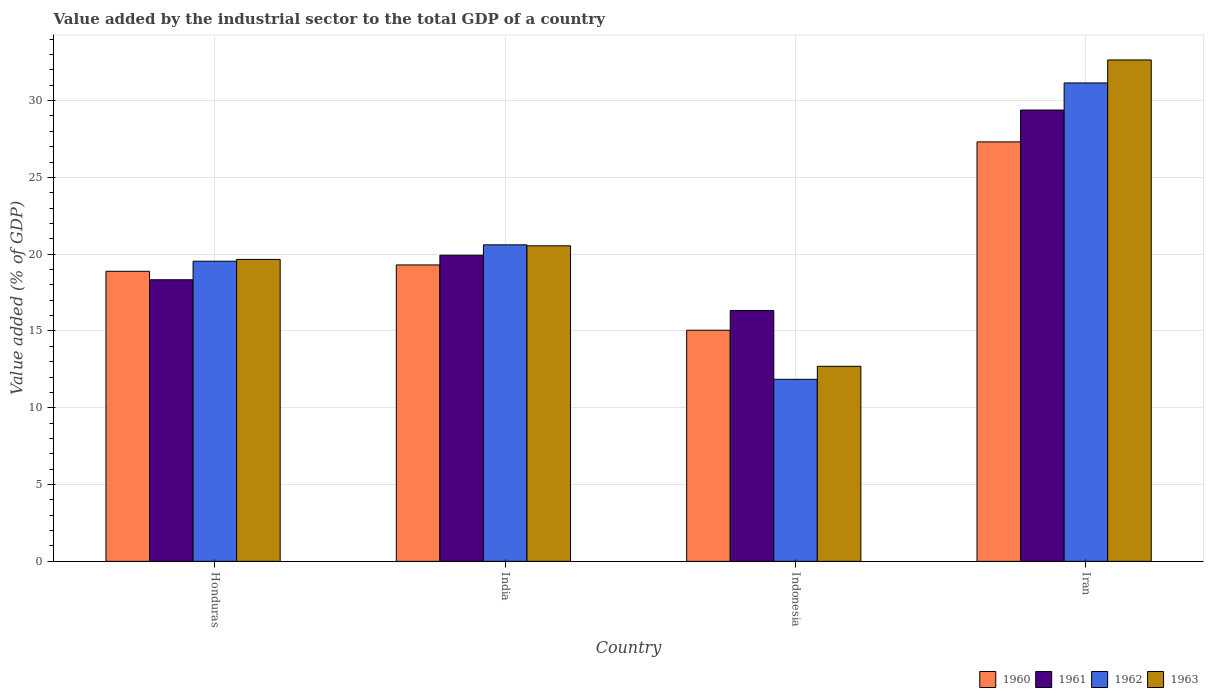How many groups of bars are there?
Give a very brief answer. 4. How many bars are there on the 3rd tick from the left?
Make the answer very short. 4. What is the label of the 1st group of bars from the left?
Make the answer very short. Honduras. What is the value added by the industrial sector to the total GDP in 1961 in India?
Ensure brevity in your answer.  19.93. Across all countries, what is the maximum value added by the industrial sector to the total GDP in 1962?
Your answer should be compact. 31.15. Across all countries, what is the minimum value added by the industrial sector to the total GDP in 1961?
Your response must be concise. 16.33. In which country was the value added by the industrial sector to the total GDP in 1962 maximum?
Your answer should be very brief. Iran. In which country was the value added by the industrial sector to the total GDP in 1963 minimum?
Provide a short and direct response. Indonesia. What is the total value added by the industrial sector to the total GDP in 1962 in the graph?
Your response must be concise. 83.15. What is the difference between the value added by the industrial sector to the total GDP in 1960 in Honduras and that in Iran?
Your response must be concise. -8.43. What is the difference between the value added by the industrial sector to the total GDP in 1961 in India and the value added by the industrial sector to the total GDP in 1963 in Honduras?
Ensure brevity in your answer.  0.27. What is the average value added by the industrial sector to the total GDP in 1962 per country?
Your response must be concise. 20.79. What is the difference between the value added by the industrial sector to the total GDP of/in 1960 and value added by the industrial sector to the total GDP of/in 1962 in Iran?
Make the answer very short. -3.84. What is the ratio of the value added by the industrial sector to the total GDP in 1962 in India to that in Iran?
Provide a succinct answer. 0.66. Is the difference between the value added by the industrial sector to the total GDP in 1960 in Honduras and Iran greater than the difference between the value added by the industrial sector to the total GDP in 1962 in Honduras and Iran?
Offer a terse response. Yes. What is the difference between the highest and the second highest value added by the industrial sector to the total GDP in 1960?
Provide a short and direct response. 0.41. What is the difference between the highest and the lowest value added by the industrial sector to the total GDP in 1963?
Your answer should be compact. 19.95. In how many countries, is the value added by the industrial sector to the total GDP in 1960 greater than the average value added by the industrial sector to the total GDP in 1960 taken over all countries?
Keep it short and to the point. 1. Is the sum of the value added by the industrial sector to the total GDP in 1961 in Honduras and Iran greater than the maximum value added by the industrial sector to the total GDP in 1962 across all countries?
Keep it short and to the point. Yes. Is it the case that in every country, the sum of the value added by the industrial sector to the total GDP in 1961 and value added by the industrial sector to the total GDP in 1960 is greater than the sum of value added by the industrial sector to the total GDP in 1963 and value added by the industrial sector to the total GDP in 1962?
Provide a short and direct response. No. What does the 4th bar from the left in Iran represents?
Your answer should be compact. 1963. What does the 1st bar from the right in Indonesia represents?
Offer a terse response. 1963. How many bars are there?
Ensure brevity in your answer.  16. How many countries are there in the graph?
Ensure brevity in your answer.  4. What is the difference between two consecutive major ticks on the Y-axis?
Offer a terse response. 5. Are the values on the major ticks of Y-axis written in scientific E-notation?
Your answer should be very brief. No. Does the graph contain any zero values?
Make the answer very short. No. What is the title of the graph?
Your answer should be compact. Value added by the industrial sector to the total GDP of a country. Does "2001" appear as one of the legend labels in the graph?
Offer a terse response. No. What is the label or title of the Y-axis?
Provide a succinct answer. Value added (% of GDP). What is the Value added (% of GDP) in 1960 in Honduras?
Your answer should be very brief. 18.89. What is the Value added (% of GDP) of 1961 in Honduras?
Make the answer very short. 18.33. What is the Value added (% of GDP) of 1962 in Honduras?
Your answer should be compact. 19.54. What is the Value added (% of GDP) in 1963 in Honduras?
Keep it short and to the point. 19.66. What is the Value added (% of GDP) of 1960 in India?
Ensure brevity in your answer.  19.3. What is the Value added (% of GDP) in 1961 in India?
Offer a terse response. 19.93. What is the Value added (% of GDP) in 1962 in India?
Make the answer very short. 20.61. What is the Value added (% of GDP) of 1963 in India?
Provide a short and direct response. 20.54. What is the Value added (% of GDP) of 1960 in Indonesia?
Make the answer very short. 15.05. What is the Value added (% of GDP) of 1961 in Indonesia?
Keep it short and to the point. 16.33. What is the Value added (% of GDP) in 1962 in Indonesia?
Your response must be concise. 11.85. What is the Value added (% of GDP) of 1963 in Indonesia?
Provide a succinct answer. 12.7. What is the Value added (% of GDP) of 1960 in Iran?
Your response must be concise. 27.31. What is the Value added (% of GDP) of 1961 in Iran?
Give a very brief answer. 29.38. What is the Value added (% of GDP) of 1962 in Iran?
Give a very brief answer. 31.15. What is the Value added (% of GDP) of 1963 in Iran?
Offer a very short reply. 32.65. Across all countries, what is the maximum Value added (% of GDP) in 1960?
Make the answer very short. 27.31. Across all countries, what is the maximum Value added (% of GDP) of 1961?
Your answer should be compact. 29.38. Across all countries, what is the maximum Value added (% of GDP) of 1962?
Offer a very short reply. 31.15. Across all countries, what is the maximum Value added (% of GDP) of 1963?
Offer a terse response. 32.65. Across all countries, what is the minimum Value added (% of GDP) of 1960?
Ensure brevity in your answer.  15.05. Across all countries, what is the minimum Value added (% of GDP) of 1961?
Give a very brief answer. 16.33. Across all countries, what is the minimum Value added (% of GDP) of 1962?
Keep it short and to the point. 11.85. Across all countries, what is the minimum Value added (% of GDP) in 1963?
Ensure brevity in your answer.  12.7. What is the total Value added (% of GDP) in 1960 in the graph?
Your response must be concise. 80.55. What is the total Value added (% of GDP) in 1961 in the graph?
Offer a terse response. 83.98. What is the total Value added (% of GDP) of 1962 in the graph?
Your response must be concise. 83.15. What is the total Value added (% of GDP) of 1963 in the graph?
Give a very brief answer. 85.55. What is the difference between the Value added (% of GDP) in 1960 in Honduras and that in India?
Provide a succinct answer. -0.41. What is the difference between the Value added (% of GDP) in 1961 in Honduras and that in India?
Give a very brief answer. -1.6. What is the difference between the Value added (% of GDP) of 1962 in Honduras and that in India?
Give a very brief answer. -1.07. What is the difference between the Value added (% of GDP) of 1963 in Honduras and that in India?
Your answer should be very brief. -0.88. What is the difference between the Value added (% of GDP) of 1960 in Honduras and that in Indonesia?
Provide a succinct answer. 3.84. What is the difference between the Value added (% of GDP) in 1961 in Honduras and that in Indonesia?
Give a very brief answer. 2. What is the difference between the Value added (% of GDP) in 1962 in Honduras and that in Indonesia?
Give a very brief answer. 7.69. What is the difference between the Value added (% of GDP) in 1963 in Honduras and that in Indonesia?
Keep it short and to the point. 6.96. What is the difference between the Value added (% of GDP) in 1960 in Honduras and that in Iran?
Ensure brevity in your answer.  -8.43. What is the difference between the Value added (% of GDP) of 1961 in Honduras and that in Iran?
Provide a short and direct response. -11.05. What is the difference between the Value added (% of GDP) of 1962 in Honduras and that in Iran?
Give a very brief answer. -11.61. What is the difference between the Value added (% of GDP) of 1963 in Honduras and that in Iran?
Offer a terse response. -12.99. What is the difference between the Value added (% of GDP) in 1960 in India and that in Indonesia?
Keep it short and to the point. 4.25. What is the difference between the Value added (% of GDP) in 1961 in India and that in Indonesia?
Offer a terse response. 3.6. What is the difference between the Value added (% of GDP) in 1962 in India and that in Indonesia?
Give a very brief answer. 8.76. What is the difference between the Value added (% of GDP) of 1963 in India and that in Indonesia?
Give a very brief answer. 7.84. What is the difference between the Value added (% of GDP) in 1960 in India and that in Iran?
Offer a very short reply. -8.01. What is the difference between the Value added (% of GDP) of 1961 in India and that in Iran?
Make the answer very short. -9.45. What is the difference between the Value added (% of GDP) of 1962 in India and that in Iran?
Offer a very short reply. -10.54. What is the difference between the Value added (% of GDP) in 1963 in India and that in Iran?
Provide a succinct answer. -12.1. What is the difference between the Value added (% of GDP) of 1960 in Indonesia and that in Iran?
Provide a short and direct response. -12.26. What is the difference between the Value added (% of GDP) of 1961 in Indonesia and that in Iran?
Ensure brevity in your answer.  -13.05. What is the difference between the Value added (% of GDP) in 1962 in Indonesia and that in Iran?
Provide a short and direct response. -19.3. What is the difference between the Value added (% of GDP) in 1963 in Indonesia and that in Iran?
Keep it short and to the point. -19.95. What is the difference between the Value added (% of GDP) in 1960 in Honduras and the Value added (% of GDP) in 1961 in India?
Give a very brief answer. -1.05. What is the difference between the Value added (% of GDP) of 1960 in Honduras and the Value added (% of GDP) of 1962 in India?
Make the answer very short. -1.72. What is the difference between the Value added (% of GDP) of 1960 in Honduras and the Value added (% of GDP) of 1963 in India?
Offer a very short reply. -1.66. What is the difference between the Value added (% of GDP) in 1961 in Honduras and the Value added (% of GDP) in 1962 in India?
Provide a succinct answer. -2.27. What is the difference between the Value added (% of GDP) of 1961 in Honduras and the Value added (% of GDP) of 1963 in India?
Your answer should be compact. -2.21. What is the difference between the Value added (% of GDP) of 1962 in Honduras and the Value added (% of GDP) of 1963 in India?
Give a very brief answer. -1. What is the difference between the Value added (% of GDP) in 1960 in Honduras and the Value added (% of GDP) in 1961 in Indonesia?
Make the answer very short. 2.56. What is the difference between the Value added (% of GDP) in 1960 in Honduras and the Value added (% of GDP) in 1962 in Indonesia?
Offer a very short reply. 7.03. What is the difference between the Value added (% of GDP) in 1960 in Honduras and the Value added (% of GDP) in 1963 in Indonesia?
Your answer should be very brief. 6.19. What is the difference between the Value added (% of GDP) in 1961 in Honduras and the Value added (% of GDP) in 1962 in Indonesia?
Your answer should be compact. 6.48. What is the difference between the Value added (% of GDP) in 1961 in Honduras and the Value added (% of GDP) in 1963 in Indonesia?
Your response must be concise. 5.64. What is the difference between the Value added (% of GDP) in 1962 in Honduras and the Value added (% of GDP) in 1963 in Indonesia?
Make the answer very short. 6.84. What is the difference between the Value added (% of GDP) of 1960 in Honduras and the Value added (% of GDP) of 1961 in Iran?
Keep it short and to the point. -10.5. What is the difference between the Value added (% of GDP) in 1960 in Honduras and the Value added (% of GDP) in 1962 in Iran?
Make the answer very short. -12.26. What is the difference between the Value added (% of GDP) of 1960 in Honduras and the Value added (% of GDP) of 1963 in Iran?
Your answer should be compact. -13.76. What is the difference between the Value added (% of GDP) of 1961 in Honduras and the Value added (% of GDP) of 1962 in Iran?
Make the answer very short. -12.81. What is the difference between the Value added (% of GDP) in 1961 in Honduras and the Value added (% of GDP) in 1963 in Iran?
Your answer should be very brief. -14.31. What is the difference between the Value added (% of GDP) in 1962 in Honduras and the Value added (% of GDP) in 1963 in Iran?
Keep it short and to the point. -13.1. What is the difference between the Value added (% of GDP) of 1960 in India and the Value added (% of GDP) of 1961 in Indonesia?
Provide a succinct answer. 2.97. What is the difference between the Value added (% of GDP) in 1960 in India and the Value added (% of GDP) in 1962 in Indonesia?
Keep it short and to the point. 7.45. What is the difference between the Value added (% of GDP) of 1960 in India and the Value added (% of GDP) of 1963 in Indonesia?
Make the answer very short. 6.6. What is the difference between the Value added (% of GDP) of 1961 in India and the Value added (% of GDP) of 1962 in Indonesia?
Ensure brevity in your answer.  8.08. What is the difference between the Value added (% of GDP) in 1961 in India and the Value added (% of GDP) in 1963 in Indonesia?
Provide a short and direct response. 7.23. What is the difference between the Value added (% of GDP) of 1962 in India and the Value added (% of GDP) of 1963 in Indonesia?
Your response must be concise. 7.91. What is the difference between the Value added (% of GDP) in 1960 in India and the Value added (% of GDP) in 1961 in Iran?
Make the answer very short. -10.09. What is the difference between the Value added (% of GDP) in 1960 in India and the Value added (% of GDP) in 1962 in Iran?
Make the answer very short. -11.85. What is the difference between the Value added (% of GDP) of 1960 in India and the Value added (% of GDP) of 1963 in Iran?
Give a very brief answer. -13.35. What is the difference between the Value added (% of GDP) in 1961 in India and the Value added (% of GDP) in 1962 in Iran?
Your answer should be very brief. -11.22. What is the difference between the Value added (% of GDP) of 1961 in India and the Value added (% of GDP) of 1963 in Iran?
Provide a succinct answer. -12.71. What is the difference between the Value added (% of GDP) of 1962 in India and the Value added (% of GDP) of 1963 in Iran?
Make the answer very short. -12.04. What is the difference between the Value added (% of GDP) in 1960 in Indonesia and the Value added (% of GDP) in 1961 in Iran?
Your answer should be very brief. -14.34. What is the difference between the Value added (% of GDP) of 1960 in Indonesia and the Value added (% of GDP) of 1962 in Iran?
Provide a succinct answer. -16.1. What is the difference between the Value added (% of GDP) in 1960 in Indonesia and the Value added (% of GDP) in 1963 in Iran?
Give a very brief answer. -17.6. What is the difference between the Value added (% of GDP) in 1961 in Indonesia and the Value added (% of GDP) in 1962 in Iran?
Provide a succinct answer. -14.82. What is the difference between the Value added (% of GDP) in 1961 in Indonesia and the Value added (% of GDP) in 1963 in Iran?
Keep it short and to the point. -16.32. What is the difference between the Value added (% of GDP) in 1962 in Indonesia and the Value added (% of GDP) in 1963 in Iran?
Provide a short and direct response. -20.79. What is the average Value added (% of GDP) in 1960 per country?
Provide a succinct answer. 20.14. What is the average Value added (% of GDP) in 1961 per country?
Provide a short and direct response. 21. What is the average Value added (% of GDP) in 1962 per country?
Offer a very short reply. 20.79. What is the average Value added (% of GDP) in 1963 per country?
Provide a short and direct response. 21.39. What is the difference between the Value added (% of GDP) of 1960 and Value added (% of GDP) of 1961 in Honduras?
Provide a succinct answer. 0.55. What is the difference between the Value added (% of GDP) of 1960 and Value added (% of GDP) of 1962 in Honduras?
Make the answer very short. -0.66. What is the difference between the Value added (% of GDP) of 1960 and Value added (% of GDP) of 1963 in Honduras?
Offer a terse response. -0.77. What is the difference between the Value added (% of GDP) in 1961 and Value added (% of GDP) in 1962 in Honduras?
Ensure brevity in your answer.  -1.21. What is the difference between the Value added (% of GDP) of 1961 and Value added (% of GDP) of 1963 in Honduras?
Give a very brief answer. -1.32. What is the difference between the Value added (% of GDP) in 1962 and Value added (% of GDP) in 1963 in Honduras?
Ensure brevity in your answer.  -0.12. What is the difference between the Value added (% of GDP) in 1960 and Value added (% of GDP) in 1961 in India?
Ensure brevity in your answer.  -0.63. What is the difference between the Value added (% of GDP) in 1960 and Value added (% of GDP) in 1962 in India?
Your answer should be very brief. -1.31. What is the difference between the Value added (% of GDP) in 1960 and Value added (% of GDP) in 1963 in India?
Your response must be concise. -1.24. What is the difference between the Value added (% of GDP) of 1961 and Value added (% of GDP) of 1962 in India?
Keep it short and to the point. -0.68. What is the difference between the Value added (% of GDP) in 1961 and Value added (% of GDP) in 1963 in India?
Your response must be concise. -0.61. What is the difference between the Value added (% of GDP) of 1962 and Value added (% of GDP) of 1963 in India?
Make the answer very short. 0.06. What is the difference between the Value added (% of GDP) in 1960 and Value added (% of GDP) in 1961 in Indonesia?
Your response must be concise. -1.28. What is the difference between the Value added (% of GDP) of 1960 and Value added (% of GDP) of 1962 in Indonesia?
Offer a very short reply. 3.2. What is the difference between the Value added (% of GDP) of 1960 and Value added (% of GDP) of 1963 in Indonesia?
Ensure brevity in your answer.  2.35. What is the difference between the Value added (% of GDP) in 1961 and Value added (% of GDP) in 1962 in Indonesia?
Your response must be concise. 4.48. What is the difference between the Value added (% of GDP) of 1961 and Value added (% of GDP) of 1963 in Indonesia?
Provide a short and direct response. 3.63. What is the difference between the Value added (% of GDP) of 1962 and Value added (% of GDP) of 1963 in Indonesia?
Give a very brief answer. -0.85. What is the difference between the Value added (% of GDP) of 1960 and Value added (% of GDP) of 1961 in Iran?
Ensure brevity in your answer.  -2.07. What is the difference between the Value added (% of GDP) in 1960 and Value added (% of GDP) in 1962 in Iran?
Ensure brevity in your answer.  -3.84. What is the difference between the Value added (% of GDP) of 1960 and Value added (% of GDP) of 1963 in Iran?
Your answer should be compact. -5.33. What is the difference between the Value added (% of GDP) in 1961 and Value added (% of GDP) in 1962 in Iran?
Offer a terse response. -1.76. What is the difference between the Value added (% of GDP) of 1961 and Value added (% of GDP) of 1963 in Iran?
Your answer should be very brief. -3.26. What is the difference between the Value added (% of GDP) in 1962 and Value added (% of GDP) in 1963 in Iran?
Make the answer very short. -1.5. What is the ratio of the Value added (% of GDP) of 1960 in Honduras to that in India?
Your answer should be compact. 0.98. What is the ratio of the Value added (% of GDP) of 1961 in Honduras to that in India?
Your answer should be very brief. 0.92. What is the ratio of the Value added (% of GDP) of 1962 in Honduras to that in India?
Give a very brief answer. 0.95. What is the ratio of the Value added (% of GDP) of 1963 in Honduras to that in India?
Your response must be concise. 0.96. What is the ratio of the Value added (% of GDP) of 1960 in Honduras to that in Indonesia?
Provide a short and direct response. 1.25. What is the ratio of the Value added (% of GDP) of 1961 in Honduras to that in Indonesia?
Give a very brief answer. 1.12. What is the ratio of the Value added (% of GDP) in 1962 in Honduras to that in Indonesia?
Your response must be concise. 1.65. What is the ratio of the Value added (% of GDP) of 1963 in Honduras to that in Indonesia?
Offer a very short reply. 1.55. What is the ratio of the Value added (% of GDP) of 1960 in Honduras to that in Iran?
Make the answer very short. 0.69. What is the ratio of the Value added (% of GDP) in 1961 in Honduras to that in Iran?
Give a very brief answer. 0.62. What is the ratio of the Value added (% of GDP) of 1962 in Honduras to that in Iran?
Ensure brevity in your answer.  0.63. What is the ratio of the Value added (% of GDP) in 1963 in Honduras to that in Iran?
Offer a very short reply. 0.6. What is the ratio of the Value added (% of GDP) in 1960 in India to that in Indonesia?
Your response must be concise. 1.28. What is the ratio of the Value added (% of GDP) in 1961 in India to that in Indonesia?
Provide a succinct answer. 1.22. What is the ratio of the Value added (% of GDP) in 1962 in India to that in Indonesia?
Offer a very short reply. 1.74. What is the ratio of the Value added (% of GDP) of 1963 in India to that in Indonesia?
Keep it short and to the point. 1.62. What is the ratio of the Value added (% of GDP) in 1960 in India to that in Iran?
Your response must be concise. 0.71. What is the ratio of the Value added (% of GDP) of 1961 in India to that in Iran?
Keep it short and to the point. 0.68. What is the ratio of the Value added (% of GDP) of 1962 in India to that in Iran?
Keep it short and to the point. 0.66. What is the ratio of the Value added (% of GDP) of 1963 in India to that in Iran?
Ensure brevity in your answer.  0.63. What is the ratio of the Value added (% of GDP) of 1960 in Indonesia to that in Iran?
Ensure brevity in your answer.  0.55. What is the ratio of the Value added (% of GDP) in 1961 in Indonesia to that in Iran?
Provide a succinct answer. 0.56. What is the ratio of the Value added (% of GDP) of 1962 in Indonesia to that in Iran?
Give a very brief answer. 0.38. What is the ratio of the Value added (% of GDP) of 1963 in Indonesia to that in Iran?
Give a very brief answer. 0.39. What is the difference between the highest and the second highest Value added (% of GDP) of 1960?
Provide a succinct answer. 8.01. What is the difference between the highest and the second highest Value added (% of GDP) in 1961?
Offer a terse response. 9.45. What is the difference between the highest and the second highest Value added (% of GDP) in 1962?
Your answer should be compact. 10.54. What is the difference between the highest and the second highest Value added (% of GDP) in 1963?
Ensure brevity in your answer.  12.1. What is the difference between the highest and the lowest Value added (% of GDP) of 1960?
Provide a short and direct response. 12.26. What is the difference between the highest and the lowest Value added (% of GDP) in 1961?
Offer a very short reply. 13.05. What is the difference between the highest and the lowest Value added (% of GDP) in 1962?
Offer a terse response. 19.3. What is the difference between the highest and the lowest Value added (% of GDP) of 1963?
Ensure brevity in your answer.  19.95. 